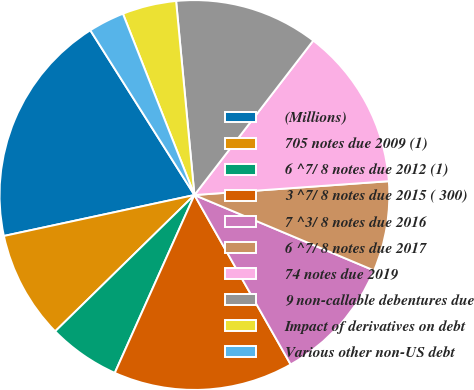<chart> <loc_0><loc_0><loc_500><loc_500><pie_chart><fcel>(Millions)<fcel>705 notes due 2009 (1)<fcel>6 ^7/ 8 notes due 2012 (1)<fcel>3 ^7/ 8 notes due 2015 ( 300)<fcel>7 ^3/ 8 notes due 2016<fcel>6 ^7/ 8 notes due 2017<fcel>74 notes due 2019<fcel>9 non-callable debentures due<fcel>Impact of derivatives on debt<fcel>Various other non-US debt<nl><fcel>19.4%<fcel>8.96%<fcel>5.97%<fcel>14.92%<fcel>10.45%<fcel>7.46%<fcel>13.43%<fcel>11.94%<fcel>4.48%<fcel>2.99%<nl></chart> 